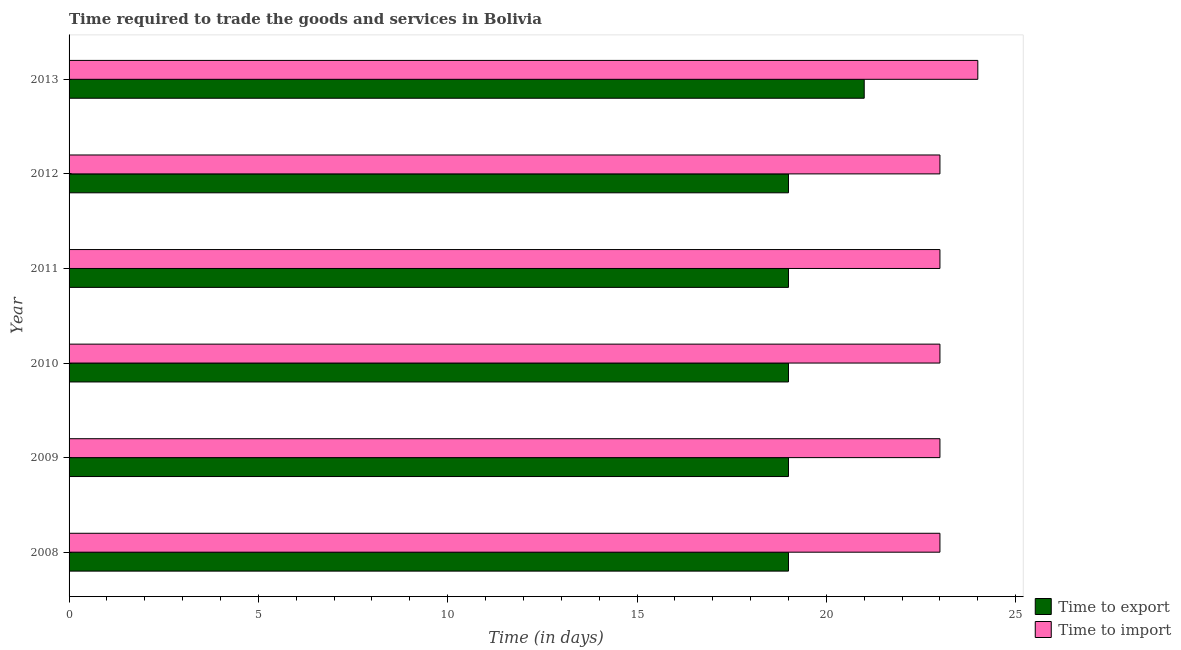What is the label of the 2nd group of bars from the top?
Keep it short and to the point. 2012. What is the time to import in 2008?
Make the answer very short. 23. Across all years, what is the maximum time to export?
Your answer should be very brief. 21. Across all years, what is the minimum time to export?
Provide a succinct answer. 19. What is the total time to export in the graph?
Provide a succinct answer. 116. What is the difference between the time to export in 2009 and that in 2013?
Provide a succinct answer. -2. What is the difference between the time to import in 2009 and the time to export in 2013?
Offer a terse response. 2. What is the average time to import per year?
Offer a terse response. 23.17. In the year 2009, what is the difference between the time to import and time to export?
Make the answer very short. 4. In how many years, is the time to import greater than 24 days?
Your answer should be very brief. 0. What is the ratio of the time to export in 2008 to that in 2013?
Offer a very short reply. 0.91. What is the difference between the highest and the second highest time to export?
Offer a terse response. 2. What is the difference between the highest and the lowest time to export?
Keep it short and to the point. 2. What does the 2nd bar from the top in 2010 represents?
Offer a very short reply. Time to export. What does the 2nd bar from the bottom in 2008 represents?
Make the answer very short. Time to import. How many bars are there?
Give a very brief answer. 12. Are all the bars in the graph horizontal?
Ensure brevity in your answer.  Yes. What is the difference between two consecutive major ticks on the X-axis?
Your response must be concise. 5. Are the values on the major ticks of X-axis written in scientific E-notation?
Offer a very short reply. No. Does the graph contain any zero values?
Ensure brevity in your answer.  No. How many legend labels are there?
Offer a very short reply. 2. What is the title of the graph?
Give a very brief answer. Time required to trade the goods and services in Bolivia. Does "National Tourists" appear as one of the legend labels in the graph?
Your answer should be compact. No. What is the label or title of the X-axis?
Your response must be concise. Time (in days). What is the Time (in days) in Time to import in 2008?
Your response must be concise. 23. What is the Time (in days) of Time to export in 2009?
Provide a short and direct response. 19. What is the Time (in days) in Time to import in 2010?
Your answer should be very brief. 23. What is the Time (in days) in Time to export in 2012?
Offer a very short reply. 19. What is the Time (in days) of Time to export in 2013?
Ensure brevity in your answer.  21. What is the total Time (in days) of Time to export in the graph?
Keep it short and to the point. 116. What is the total Time (in days) in Time to import in the graph?
Make the answer very short. 139. What is the difference between the Time (in days) of Time to import in 2008 and that in 2009?
Provide a short and direct response. 0. What is the difference between the Time (in days) of Time to export in 2008 and that in 2010?
Provide a succinct answer. 0. What is the difference between the Time (in days) in Time to import in 2008 and that in 2010?
Your answer should be compact. 0. What is the difference between the Time (in days) of Time to export in 2008 and that in 2012?
Give a very brief answer. 0. What is the difference between the Time (in days) in Time to import in 2008 and that in 2012?
Your response must be concise. 0. What is the difference between the Time (in days) in Time to export in 2008 and that in 2013?
Keep it short and to the point. -2. What is the difference between the Time (in days) of Time to export in 2009 and that in 2010?
Provide a short and direct response. 0. What is the difference between the Time (in days) of Time to import in 2009 and that in 2010?
Your answer should be very brief. 0. What is the difference between the Time (in days) in Time to export in 2009 and that in 2011?
Provide a succinct answer. 0. What is the difference between the Time (in days) of Time to import in 2009 and that in 2011?
Offer a very short reply. 0. What is the difference between the Time (in days) in Time to export in 2009 and that in 2013?
Provide a short and direct response. -2. What is the difference between the Time (in days) of Time to import in 2009 and that in 2013?
Ensure brevity in your answer.  -1. What is the difference between the Time (in days) in Time to export in 2010 and that in 2011?
Give a very brief answer. 0. What is the difference between the Time (in days) of Time to import in 2010 and that in 2011?
Make the answer very short. 0. What is the difference between the Time (in days) of Time to export in 2010 and that in 2012?
Keep it short and to the point. 0. What is the difference between the Time (in days) in Time to import in 2010 and that in 2012?
Your answer should be very brief. 0. What is the difference between the Time (in days) of Time to export in 2010 and that in 2013?
Offer a very short reply. -2. What is the difference between the Time (in days) of Time to export in 2011 and that in 2012?
Keep it short and to the point. 0. What is the difference between the Time (in days) of Time to import in 2011 and that in 2013?
Offer a terse response. -1. What is the difference between the Time (in days) in Time to export in 2008 and the Time (in days) in Time to import in 2009?
Provide a succinct answer. -4. What is the difference between the Time (in days) of Time to export in 2008 and the Time (in days) of Time to import in 2010?
Give a very brief answer. -4. What is the difference between the Time (in days) of Time to export in 2009 and the Time (in days) of Time to import in 2011?
Make the answer very short. -4. What is the difference between the Time (in days) in Time to export in 2010 and the Time (in days) in Time to import in 2011?
Your response must be concise. -4. What is the difference between the Time (in days) in Time to export in 2011 and the Time (in days) in Time to import in 2013?
Give a very brief answer. -5. What is the difference between the Time (in days) of Time to export in 2012 and the Time (in days) of Time to import in 2013?
Provide a succinct answer. -5. What is the average Time (in days) in Time to export per year?
Provide a short and direct response. 19.33. What is the average Time (in days) of Time to import per year?
Offer a very short reply. 23.17. In the year 2008, what is the difference between the Time (in days) in Time to export and Time (in days) in Time to import?
Offer a very short reply. -4. In the year 2009, what is the difference between the Time (in days) in Time to export and Time (in days) in Time to import?
Offer a terse response. -4. In the year 2010, what is the difference between the Time (in days) in Time to export and Time (in days) in Time to import?
Your response must be concise. -4. In the year 2011, what is the difference between the Time (in days) in Time to export and Time (in days) in Time to import?
Give a very brief answer. -4. In the year 2013, what is the difference between the Time (in days) in Time to export and Time (in days) in Time to import?
Your response must be concise. -3. What is the ratio of the Time (in days) in Time to export in 2008 to that in 2009?
Your answer should be compact. 1. What is the ratio of the Time (in days) in Time to import in 2008 to that in 2009?
Your answer should be very brief. 1. What is the ratio of the Time (in days) in Time to import in 2008 to that in 2010?
Your answer should be very brief. 1. What is the ratio of the Time (in days) of Time to export in 2008 to that in 2011?
Ensure brevity in your answer.  1. What is the ratio of the Time (in days) of Time to export in 2008 to that in 2012?
Provide a short and direct response. 1. What is the ratio of the Time (in days) of Time to import in 2008 to that in 2012?
Provide a succinct answer. 1. What is the ratio of the Time (in days) of Time to export in 2008 to that in 2013?
Offer a very short reply. 0.9. What is the ratio of the Time (in days) of Time to import in 2009 to that in 2012?
Your response must be concise. 1. What is the ratio of the Time (in days) of Time to export in 2009 to that in 2013?
Make the answer very short. 0.9. What is the ratio of the Time (in days) of Time to import in 2009 to that in 2013?
Your response must be concise. 0.96. What is the ratio of the Time (in days) in Time to export in 2010 to that in 2011?
Offer a terse response. 1. What is the ratio of the Time (in days) of Time to import in 2010 to that in 2011?
Offer a very short reply. 1. What is the ratio of the Time (in days) of Time to export in 2010 to that in 2012?
Make the answer very short. 1. What is the ratio of the Time (in days) of Time to import in 2010 to that in 2012?
Offer a very short reply. 1. What is the ratio of the Time (in days) in Time to export in 2010 to that in 2013?
Your answer should be very brief. 0.9. What is the ratio of the Time (in days) in Time to export in 2011 to that in 2012?
Give a very brief answer. 1. What is the ratio of the Time (in days) in Time to export in 2011 to that in 2013?
Your response must be concise. 0.9. What is the ratio of the Time (in days) in Time to import in 2011 to that in 2013?
Your response must be concise. 0.96. What is the ratio of the Time (in days) of Time to export in 2012 to that in 2013?
Your answer should be very brief. 0.9. What is the ratio of the Time (in days) in Time to import in 2012 to that in 2013?
Ensure brevity in your answer.  0.96. What is the difference between the highest and the second highest Time (in days) of Time to export?
Provide a short and direct response. 2. What is the difference between the highest and the second highest Time (in days) of Time to import?
Offer a terse response. 1. What is the difference between the highest and the lowest Time (in days) in Time to export?
Your answer should be very brief. 2. What is the difference between the highest and the lowest Time (in days) of Time to import?
Make the answer very short. 1. 